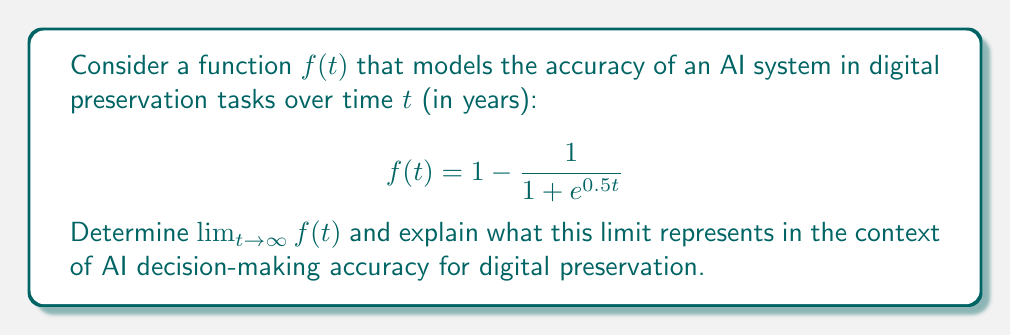Provide a solution to this math problem. To solve this problem, we'll follow these steps:

1) First, let's examine the structure of the function:
   $$f(t) = 1 - \frac{1}{1 + e^{0.5t}}$$

2) As $t$ approaches infinity, $e^{0.5t}$ will grow exponentially large. Let's consider what happens to the fraction $\frac{1}{1 + e^{0.5t}}$ as $t \to \infty$:

   $$\lim_{t \to \infty} \frac{1}{1 + e^{0.5t}} = \frac{1}{\infty} = 0$$

3) Now, we can determine the limit of the entire function:

   $$\lim_{t \to \infty} f(t) = \lim_{t \to \infty} (1 - \frac{1}{1 + e^{0.5t}})$$
   $$= 1 - \lim_{t \to \infty} \frac{1}{1 + e^{0.5t}}$$
   $$= 1 - 0 = 1$$

4) In the context of AI decision-making accuracy for digital preservation, this limit represents the theoretical maximum accuracy that the AI system can achieve over an extended period of time. As time approaches infinity, the function approaches 1, indicating that the AI's accuracy in digital preservation tasks asymptotically approaches 100%.

5) It's important to note that while this mathematical model suggests perfect accuracy is theoretically possible, in practice, there may be limitations or factors not accounted for in this idealized model. Ethical considerations in AI development and implementation, such as bias mitigation and transparency, would be crucial to address alongside improving accuracy.
Answer: The limit of the function as $t$ approaches infinity is 1, or 100% accuracy:

$$\lim_{t \to \infty} f(t) = 1$$

This represents the theoretical maximum accuracy of the AI system in digital preservation tasks over an extended period of time. 